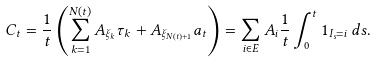<formula> <loc_0><loc_0><loc_500><loc_500>C _ { t } = \frac { 1 } { t } \left ( \sum _ { k = 1 } ^ { N ( t ) } A _ { \xi _ { k } } \tau _ { k } + A _ { \xi _ { N ( t ) + 1 } } a _ { t } \right ) = \sum _ { i \in E } A _ { i } \frac { 1 } { t } \int _ { 0 } ^ { t } 1 _ { I _ { s } = i } \, d s .</formula> 